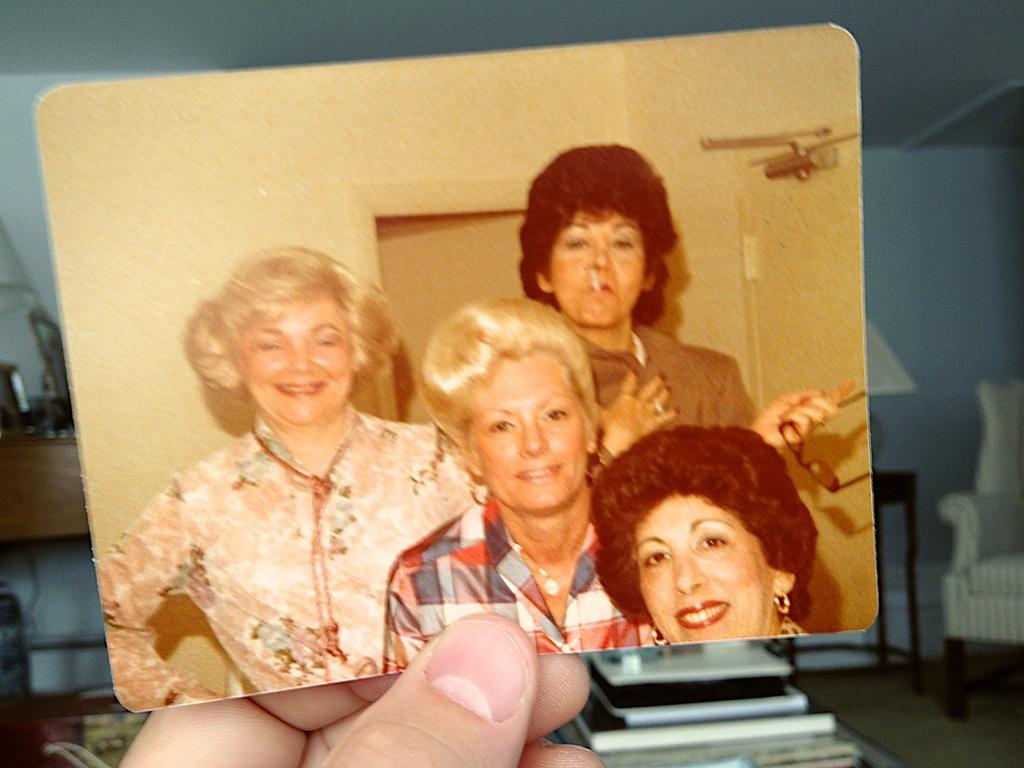How would you summarize this image in a sentence or two? In this image, we can see a hand holding a photograph contains persons. There is couch in the right side of the image. There are books at the bottom of the image. 